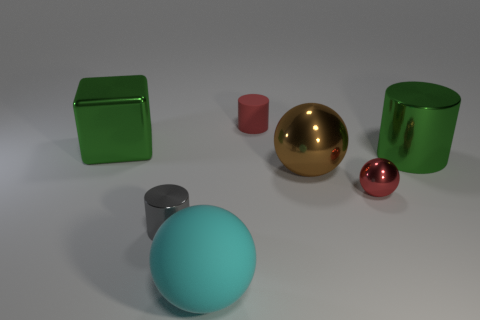Subtract all matte cylinders. How many cylinders are left? 2 Subtract 1 cylinders. How many cylinders are left? 2 Add 2 brown shiny things. How many objects exist? 9 Subtract all spheres. How many objects are left? 4 Subtract 0 cyan cubes. How many objects are left? 7 Subtract all tiny green cylinders. Subtract all large green metal objects. How many objects are left? 5 Add 6 tiny shiny spheres. How many tiny shiny spheres are left? 7 Add 3 big purple shiny cubes. How many big purple shiny cubes exist? 3 